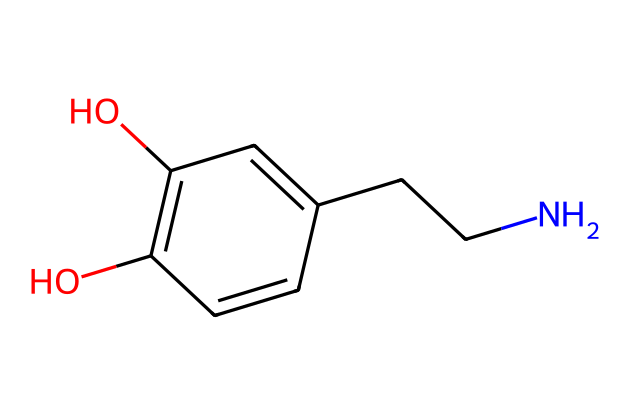What is the molecular formula of dopamine? To determine the molecular formula, we count the number of each type of atom in the chemical structure represented by the SMILES. In this case, we see 8 carbon (C) atoms, 11 hydrogen (H) atoms, 2 oxygen (O) atoms, and 1 nitrogen (N) atom. Therefore, the molecular formula is C8H11N2O2.
Answer: C8H11N2O2 How many hydroxyl (-OH) groups are present in the structure? Examining the chemical structure, the hydroxyl groups are indicated by the presence of -OH functional groups. Upon inspection, we can see two -OH groups attached to the aromatic ring of the molecule.
Answer: 2 What type of molecule is dopamine primarily classified as? Dopamine is primarily classified as a neurotransmitter, which is a type of signaling molecule in the nervous system. It plays a crucial role in transmitting signals between neurons.
Answer: neurotransmitter Which functional group indicates that dopamine is an alcohol? The presence of hydroxyl (-OH) groups in the molecular structure indicates that dopamine has alcoholic characteristics. Each -OH group represents an alcohol functional group.
Answer: -OH How many rings are in the dopamine structure? Analyzing the structure, dopamine features only one aromatic ring. This can be identified by the cyclic arrangement of carbon atoms with alternating double bonds.
Answer: 1 What is the significance of the nitrogen atom in the dopamine structure? The nitrogen atom contributes to the amine functional group of dopamine. This feature is significant as it helps in dopamine's role as a neurotransmitter, providing it with basic properties necessary for neurotransmitter activity.
Answer: amine 